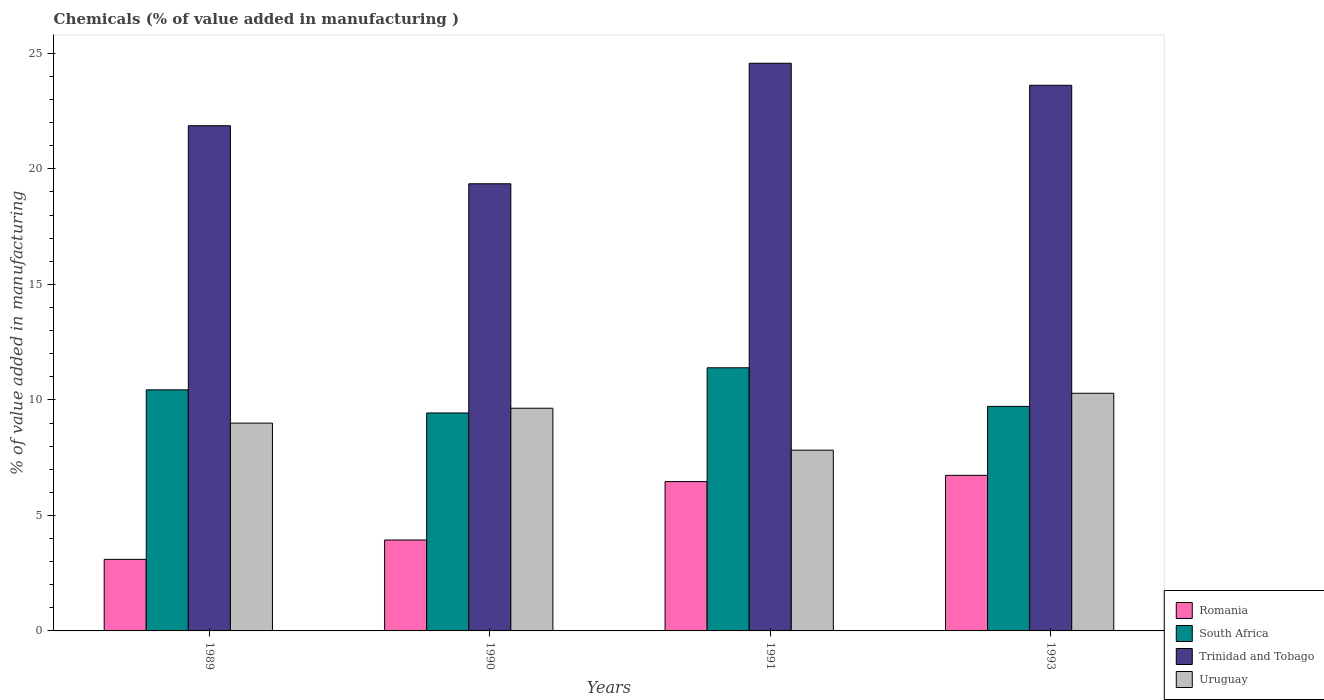How many groups of bars are there?
Your response must be concise. 4. Are the number of bars per tick equal to the number of legend labels?
Provide a short and direct response. Yes. Are the number of bars on each tick of the X-axis equal?
Your response must be concise. Yes. How many bars are there on the 3rd tick from the left?
Keep it short and to the point. 4. What is the label of the 4th group of bars from the left?
Your response must be concise. 1993. What is the value added in manufacturing chemicals in South Africa in 1990?
Your response must be concise. 9.44. Across all years, what is the maximum value added in manufacturing chemicals in South Africa?
Offer a very short reply. 11.39. Across all years, what is the minimum value added in manufacturing chemicals in Uruguay?
Your answer should be very brief. 7.82. In which year was the value added in manufacturing chemicals in Uruguay minimum?
Keep it short and to the point. 1991. What is the total value added in manufacturing chemicals in Trinidad and Tobago in the graph?
Give a very brief answer. 89.42. What is the difference between the value added in manufacturing chemicals in Romania in 1989 and that in 1990?
Your response must be concise. -0.84. What is the difference between the value added in manufacturing chemicals in Romania in 1991 and the value added in manufacturing chemicals in Uruguay in 1990?
Ensure brevity in your answer.  -3.18. What is the average value added in manufacturing chemicals in Uruguay per year?
Offer a terse response. 9.19. In the year 1993, what is the difference between the value added in manufacturing chemicals in Uruguay and value added in manufacturing chemicals in Trinidad and Tobago?
Provide a short and direct response. -13.33. In how many years, is the value added in manufacturing chemicals in South Africa greater than 18 %?
Keep it short and to the point. 0. What is the ratio of the value added in manufacturing chemicals in Uruguay in 1989 to that in 1990?
Make the answer very short. 0.93. What is the difference between the highest and the second highest value added in manufacturing chemicals in Trinidad and Tobago?
Your response must be concise. 0.95. What is the difference between the highest and the lowest value added in manufacturing chemicals in Romania?
Provide a succinct answer. 3.64. What does the 1st bar from the left in 1989 represents?
Make the answer very short. Romania. What does the 3rd bar from the right in 1990 represents?
Give a very brief answer. South Africa. Is it the case that in every year, the sum of the value added in manufacturing chemicals in Trinidad and Tobago and value added in manufacturing chemicals in South Africa is greater than the value added in manufacturing chemicals in Uruguay?
Keep it short and to the point. Yes. How many bars are there?
Keep it short and to the point. 16. Are all the bars in the graph horizontal?
Provide a short and direct response. No. Are the values on the major ticks of Y-axis written in scientific E-notation?
Offer a very short reply. No. Does the graph contain any zero values?
Make the answer very short. No. Where does the legend appear in the graph?
Make the answer very short. Bottom right. How are the legend labels stacked?
Make the answer very short. Vertical. What is the title of the graph?
Provide a succinct answer. Chemicals (% of value added in manufacturing ). What is the label or title of the X-axis?
Offer a terse response. Years. What is the label or title of the Y-axis?
Offer a terse response. % of value added in manufacturing. What is the % of value added in manufacturing of Romania in 1989?
Give a very brief answer. 3.1. What is the % of value added in manufacturing of South Africa in 1989?
Make the answer very short. 10.43. What is the % of value added in manufacturing in Trinidad and Tobago in 1989?
Offer a terse response. 21.87. What is the % of value added in manufacturing of Uruguay in 1989?
Your answer should be compact. 9. What is the % of value added in manufacturing of Romania in 1990?
Your answer should be compact. 3.94. What is the % of value added in manufacturing in South Africa in 1990?
Offer a terse response. 9.44. What is the % of value added in manufacturing in Trinidad and Tobago in 1990?
Offer a terse response. 19.36. What is the % of value added in manufacturing in Uruguay in 1990?
Ensure brevity in your answer.  9.64. What is the % of value added in manufacturing of Romania in 1991?
Your answer should be very brief. 6.46. What is the % of value added in manufacturing of South Africa in 1991?
Offer a terse response. 11.39. What is the % of value added in manufacturing of Trinidad and Tobago in 1991?
Your response must be concise. 24.57. What is the % of value added in manufacturing in Uruguay in 1991?
Offer a terse response. 7.82. What is the % of value added in manufacturing in Romania in 1993?
Your answer should be compact. 6.73. What is the % of value added in manufacturing in South Africa in 1993?
Your response must be concise. 9.72. What is the % of value added in manufacturing of Trinidad and Tobago in 1993?
Make the answer very short. 23.62. What is the % of value added in manufacturing of Uruguay in 1993?
Your answer should be compact. 10.29. Across all years, what is the maximum % of value added in manufacturing of Romania?
Offer a terse response. 6.73. Across all years, what is the maximum % of value added in manufacturing in South Africa?
Offer a terse response. 11.39. Across all years, what is the maximum % of value added in manufacturing of Trinidad and Tobago?
Give a very brief answer. 24.57. Across all years, what is the maximum % of value added in manufacturing of Uruguay?
Offer a very short reply. 10.29. Across all years, what is the minimum % of value added in manufacturing of Romania?
Keep it short and to the point. 3.1. Across all years, what is the minimum % of value added in manufacturing of South Africa?
Your answer should be very brief. 9.44. Across all years, what is the minimum % of value added in manufacturing in Trinidad and Tobago?
Provide a short and direct response. 19.36. Across all years, what is the minimum % of value added in manufacturing in Uruguay?
Your response must be concise. 7.82. What is the total % of value added in manufacturing in Romania in the graph?
Provide a short and direct response. 20.23. What is the total % of value added in manufacturing of South Africa in the graph?
Provide a succinct answer. 40.98. What is the total % of value added in manufacturing of Trinidad and Tobago in the graph?
Your answer should be compact. 89.42. What is the total % of value added in manufacturing in Uruguay in the graph?
Your response must be concise. 36.75. What is the difference between the % of value added in manufacturing in Romania in 1989 and that in 1990?
Make the answer very short. -0.84. What is the difference between the % of value added in manufacturing in South Africa in 1989 and that in 1990?
Give a very brief answer. 1. What is the difference between the % of value added in manufacturing of Trinidad and Tobago in 1989 and that in 1990?
Give a very brief answer. 2.51. What is the difference between the % of value added in manufacturing in Uruguay in 1989 and that in 1990?
Provide a succinct answer. -0.64. What is the difference between the % of value added in manufacturing in Romania in 1989 and that in 1991?
Keep it short and to the point. -3.37. What is the difference between the % of value added in manufacturing in South Africa in 1989 and that in 1991?
Give a very brief answer. -0.96. What is the difference between the % of value added in manufacturing in Trinidad and Tobago in 1989 and that in 1991?
Your answer should be compact. -2.7. What is the difference between the % of value added in manufacturing of Uruguay in 1989 and that in 1991?
Offer a terse response. 1.17. What is the difference between the % of value added in manufacturing of Romania in 1989 and that in 1993?
Ensure brevity in your answer.  -3.64. What is the difference between the % of value added in manufacturing of South Africa in 1989 and that in 1993?
Offer a very short reply. 0.72. What is the difference between the % of value added in manufacturing in Trinidad and Tobago in 1989 and that in 1993?
Provide a succinct answer. -1.75. What is the difference between the % of value added in manufacturing of Uruguay in 1989 and that in 1993?
Ensure brevity in your answer.  -1.29. What is the difference between the % of value added in manufacturing in Romania in 1990 and that in 1991?
Ensure brevity in your answer.  -2.53. What is the difference between the % of value added in manufacturing of South Africa in 1990 and that in 1991?
Offer a terse response. -1.96. What is the difference between the % of value added in manufacturing of Trinidad and Tobago in 1990 and that in 1991?
Make the answer very short. -5.22. What is the difference between the % of value added in manufacturing in Uruguay in 1990 and that in 1991?
Give a very brief answer. 1.82. What is the difference between the % of value added in manufacturing of Romania in 1990 and that in 1993?
Your answer should be compact. -2.8. What is the difference between the % of value added in manufacturing of South Africa in 1990 and that in 1993?
Give a very brief answer. -0.28. What is the difference between the % of value added in manufacturing in Trinidad and Tobago in 1990 and that in 1993?
Provide a succinct answer. -4.26. What is the difference between the % of value added in manufacturing of Uruguay in 1990 and that in 1993?
Your answer should be compact. -0.65. What is the difference between the % of value added in manufacturing in Romania in 1991 and that in 1993?
Give a very brief answer. -0.27. What is the difference between the % of value added in manufacturing of South Africa in 1991 and that in 1993?
Make the answer very short. 1.67. What is the difference between the % of value added in manufacturing in Trinidad and Tobago in 1991 and that in 1993?
Ensure brevity in your answer.  0.95. What is the difference between the % of value added in manufacturing in Uruguay in 1991 and that in 1993?
Make the answer very short. -2.46. What is the difference between the % of value added in manufacturing of Romania in 1989 and the % of value added in manufacturing of South Africa in 1990?
Keep it short and to the point. -6.34. What is the difference between the % of value added in manufacturing of Romania in 1989 and the % of value added in manufacturing of Trinidad and Tobago in 1990?
Your answer should be very brief. -16.26. What is the difference between the % of value added in manufacturing of Romania in 1989 and the % of value added in manufacturing of Uruguay in 1990?
Your answer should be compact. -6.54. What is the difference between the % of value added in manufacturing of South Africa in 1989 and the % of value added in manufacturing of Trinidad and Tobago in 1990?
Keep it short and to the point. -8.92. What is the difference between the % of value added in manufacturing in South Africa in 1989 and the % of value added in manufacturing in Uruguay in 1990?
Make the answer very short. 0.79. What is the difference between the % of value added in manufacturing of Trinidad and Tobago in 1989 and the % of value added in manufacturing of Uruguay in 1990?
Give a very brief answer. 12.23. What is the difference between the % of value added in manufacturing of Romania in 1989 and the % of value added in manufacturing of South Africa in 1991?
Provide a short and direct response. -8.29. What is the difference between the % of value added in manufacturing in Romania in 1989 and the % of value added in manufacturing in Trinidad and Tobago in 1991?
Offer a very short reply. -21.47. What is the difference between the % of value added in manufacturing of Romania in 1989 and the % of value added in manufacturing of Uruguay in 1991?
Your answer should be very brief. -4.73. What is the difference between the % of value added in manufacturing in South Africa in 1989 and the % of value added in manufacturing in Trinidad and Tobago in 1991?
Ensure brevity in your answer.  -14.14. What is the difference between the % of value added in manufacturing in South Africa in 1989 and the % of value added in manufacturing in Uruguay in 1991?
Make the answer very short. 2.61. What is the difference between the % of value added in manufacturing of Trinidad and Tobago in 1989 and the % of value added in manufacturing of Uruguay in 1991?
Give a very brief answer. 14.04. What is the difference between the % of value added in manufacturing of Romania in 1989 and the % of value added in manufacturing of South Africa in 1993?
Provide a succinct answer. -6.62. What is the difference between the % of value added in manufacturing in Romania in 1989 and the % of value added in manufacturing in Trinidad and Tobago in 1993?
Offer a very short reply. -20.52. What is the difference between the % of value added in manufacturing in Romania in 1989 and the % of value added in manufacturing in Uruguay in 1993?
Offer a very short reply. -7.19. What is the difference between the % of value added in manufacturing in South Africa in 1989 and the % of value added in manufacturing in Trinidad and Tobago in 1993?
Give a very brief answer. -13.18. What is the difference between the % of value added in manufacturing in South Africa in 1989 and the % of value added in manufacturing in Uruguay in 1993?
Your answer should be compact. 0.15. What is the difference between the % of value added in manufacturing of Trinidad and Tobago in 1989 and the % of value added in manufacturing of Uruguay in 1993?
Provide a succinct answer. 11.58. What is the difference between the % of value added in manufacturing of Romania in 1990 and the % of value added in manufacturing of South Africa in 1991?
Provide a succinct answer. -7.46. What is the difference between the % of value added in manufacturing of Romania in 1990 and the % of value added in manufacturing of Trinidad and Tobago in 1991?
Ensure brevity in your answer.  -20.64. What is the difference between the % of value added in manufacturing of Romania in 1990 and the % of value added in manufacturing of Uruguay in 1991?
Give a very brief answer. -3.89. What is the difference between the % of value added in manufacturing in South Africa in 1990 and the % of value added in manufacturing in Trinidad and Tobago in 1991?
Give a very brief answer. -15.14. What is the difference between the % of value added in manufacturing of South Africa in 1990 and the % of value added in manufacturing of Uruguay in 1991?
Provide a short and direct response. 1.61. What is the difference between the % of value added in manufacturing of Trinidad and Tobago in 1990 and the % of value added in manufacturing of Uruguay in 1991?
Offer a very short reply. 11.53. What is the difference between the % of value added in manufacturing in Romania in 1990 and the % of value added in manufacturing in South Africa in 1993?
Give a very brief answer. -5.78. What is the difference between the % of value added in manufacturing of Romania in 1990 and the % of value added in manufacturing of Trinidad and Tobago in 1993?
Your answer should be compact. -19.68. What is the difference between the % of value added in manufacturing of Romania in 1990 and the % of value added in manufacturing of Uruguay in 1993?
Your answer should be very brief. -6.35. What is the difference between the % of value added in manufacturing of South Africa in 1990 and the % of value added in manufacturing of Trinidad and Tobago in 1993?
Your response must be concise. -14.18. What is the difference between the % of value added in manufacturing in South Africa in 1990 and the % of value added in manufacturing in Uruguay in 1993?
Give a very brief answer. -0.85. What is the difference between the % of value added in manufacturing of Trinidad and Tobago in 1990 and the % of value added in manufacturing of Uruguay in 1993?
Ensure brevity in your answer.  9.07. What is the difference between the % of value added in manufacturing in Romania in 1991 and the % of value added in manufacturing in South Africa in 1993?
Give a very brief answer. -3.25. What is the difference between the % of value added in manufacturing in Romania in 1991 and the % of value added in manufacturing in Trinidad and Tobago in 1993?
Provide a succinct answer. -17.15. What is the difference between the % of value added in manufacturing in Romania in 1991 and the % of value added in manufacturing in Uruguay in 1993?
Your answer should be very brief. -3.82. What is the difference between the % of value added in manufacturing in South Africa in 1991 and the % of value added in manufacturing in Trinidad and Tobago in 1993?
Offer a terse response. -12.23. What is the difference between the % of value added in manufacturing of South Africa in 1991 and the % of value added in manufacturing of Uruguay in 1993?
Give a very brief answer. 1.1. What is the difference between the % of value added in manufacturing of Trinidad and Tobago in 1991 and the % of value added in manufacturing of Uruguay in 1993?
Provide a short and direct response. 14.28. What is the average % of value added in manufacturing of Romania per year?
Your response must be concise. 5.06. What is the average % of value added in manufacturing of South Africa per year?
Your answer should be very brief. 10.24. What is the average % of value added in manufacturing of Trinidad and Tobago per year?
Offer a terse response. 22.35. What is the average % of value added in manufacturing of Uruguay per year?
Your answer should be very brief. 9.19. In the year 1989, what is the difference between the % of value added in manufacturing of Romania and % of value added in manufacturing of South Africa?
Make the answer very short. -7.34. In the year 1989, what is the difference between the % of value added in manufacturing in Romania and % of value added in manufacturing in Trinidad and Tobago?
Give a very brief answer. -18.77. In the year 1989, what is the difference between the % of value added in manufacturing in Romania and % of value added in manufacturing in Uruguay?
Offer a very short reply. -5.9. In the year 1989, what is the difference between the % of value added in manufacturing in South Africa and % of value added in manufacturing in Trinidad and Tobago?
Ensure brevity in your answer.  -11.43. In the year 1989, what is the difference between the % of value added in manufacturing in South Africa and % of value added in manufacturing in Uruguay?
Your answer should be very brief. 1.44. In the year 1989, what is the difference between the % of value added in manufacturing of Trinidad and Tobago and % of value added in manufacturing of Uruguay?
Ensure brevity in your answer.  12.87. In the year 1990, what is the difference between the % of value added in manufacturing of Romania and % of value added in manufacturing of South Africa?
Keep it short and to the point. -5.5. In the year 1990, what is the difference between the % of value added in manufacturing of Romania and % of value added in manufacturing of Trinidad and Tobago?
Provide a succinct answer. -15.42. In the year 1990, what is the difference between the % of value added in manufacturing in Romania and % of value added in manufacturing in Uruguay?
Keep it short and to the point. -5.7. In the year 1990, what is the difference between the % of value added in manufacturing of South Africa and % of value added in manufacturing of Trinidad and Tobago?
Provide a succinct answer. -9.92. In the year 1990, what is the difference between the % of value added in manufacturing in South Africa and % of value added in manufacturing in Uruguay?
Your response must be concise. -0.2. In the year 1990, what is the difference between the % of value added in manufacturing of Trinidad and Tobago and % of value added in manufacturing of Uruguay?
Provide a short and direct response. 9.72. In the year 1991, what is the difference between the % of value added in manufacturing of Romania and % of value added in manufacturing of South Africa?
Provide a succinct answer. -4.93. In the year 1991, what is the difference between the % of value added in manufacturing in Romania and % of value added in manufacturing in Trinidad and Tobago?
Your answer should be compact. -18.11. In the year 1991, what is the difference between the % of value added in manufacturing of Romania and % of value added in manufacturing of Uruguay?
Offer a very short reply. -1.36. In the year 1991, what is the difference between the % of value added in manufacturing of South Africa and % of value added in manufacturing of Trinidad and Tobago?
Give a very brief answer. -13.18. In the year 1991, what is the difference between the % of value added in manufacturing of South Africa and % of value added in manufacturing of Uruguay?
Offer a terse response. 3.57. In the year 1991, what is the difference between the % of value added in manufacturing in Trinidad and Tobago and % of value added in manufacturing in Uruguay?
Keep it short and to the point. 16.75. In the year 1993, what is the difference between the % of value added in manufacturing in Romania and % of value added in manufacturing in South Africa?
Offer a very short reply. -2.98. In the year 1993, what is the difference between the % of value added in manufacturing of Romania and % of value added in manufacturing of Trinidad and Tobago?
Offer a terse response. -16.88. In the year 1993, what is the difference between the % of value added in manufacturing of Romania and % of value added in manufacturing of Uruguay?
Your answer should be very brief. -3.55. In the year 1993, what is the difference between the % of value added in manufacturing of South Africa and % of value added in manufacturing of Trinidad and Tobago?
Make the answer very short. -13.9. In the year 1993, what is the difference between the % of value added in manufacturing in South Africa and % of value added in manufacturing in Uruguay?
Your answer should be very brief. -0.57. In the year 1993, what is the difference between the % of value added in manufacturing in Trinidad and Tobago and % of value added in manufacturing in Uruguay?
Offer a terse response. 13.33. What is the ratio of the % of value added in manufacturing in Romania in 1989 to that in 1990?
Offer a very short reply. 0.79. What is the ratio of the % of value added in manufacturing of South Africa in 1989 to that in 1990?
Your response must be concise. 1.11. What is the ratio of the % of value added in manufacturing in Trinidad and Tobago in 1989 to that in 1990?
Your answer should be compact. 1.13. What is the ratio of the % of value added in manufacturing of Uruguay in 1989 to that in 1990?
Your answer should be compact. 0.93. What is the ratio of the % of value added in manufacturing of Romania in 1989 to that in 1991?
Make the answer very short. 0.48. What is the ratio of the % of value added in manufacturing of South Africa in 1989 to that in 1991?
Provide a short and direct response. 0.92. What is the ratio of the % of value added in manufacturing in Trinidad and Tobago in 1989 to that in 1991?
Your answer should be compact. 0.89. What is the ratio of the % of value added in manufacturing in Uruguay in 1989 to that in 1991?
Provide a succinct answer. 1.15. What is the ratio of the % of value added in manufacturing in Romania in 1989 to that in 1993?
Offer a terse response. 0.46. What is the ratio of the % of value added in manufacturing in South Africa in 1989 to that in 1993?
Your answer should be very brief. 1.07. What is the ratio of the % of value added in manufacturing of Trinidad and Tobago in 1989 to that in 1993?
Provide a succinct answer. 0.93. What is the ratio of the % of value added in manufacturing in Uruguay in 1989 to that in 1993?
Provide a short and direct response. 0.87. What is the ratio of the % of value added in manufacturing in Romania in 1990 to that in 1991?
Your answer should be compact. 0.61. What is the ratio of the % of value added in manufacturing of South Africa in 1990 to that in 1991?
Offer a very short reply. 0.83. What is the ratio of the % of value added in manufacturing of Trinidad and Tobago in 1990 to that in 1991?
Ensure brevity in your answer.  0.79. What is the ratio of the % of value added in manufacturing of Uruguay in 1990 to that in 1991?
Ensure brevity in your answer.  1.23. What is the ratio of the % of value added in manufacturing in Romania in 1990 to that in 1993?
Keep it short and to the point. 0.58. What is the ratio of the % of value added in manufacturing in South Africa in 1990 to that in 1993?
Keep it short and to the point. 0.97. What is the ratio of the % of value added in manufacturing of Trinidad and Tobago in 1990 to that in 1993?
Offer a terse response. 0.82. What is the ratio of the % of value added in manufacturing in Uruguay in 1990 to that in 1993?
Keep it short and to the point. 0.94. What is the ratio of the % of value added in manufacturing of Romania in 1991 to that in 1993?
Provide a short and direct response. 0.96. What is the ratio of the % of value added in manufacturing of South Africa in 1991 to that in 1993?
Your answer should be compact. 1.17. What is the ratio of the % of value added in manufacturing in Trinidad and Tobago in 1991 to that in 1993?
Provide a short and direct response. 1.04. What is the ratio of the % of value added in manufacturing in Uruguay in 1991 to that in 1993?
Provide a short and direct response. 0.76. What is the difference between the highest and the second highest % of value added in manufacturing in Romania?
Your answer should be very brief. 0.27. What is the difference between the highest and the second highest % of value added in manufacturing of South Africa?
Your answer should be compact. 0.96. What is the difference between the highest and the second highest % of value added in manufacturing of Trinidad and Tobago?
Your response must be concise. 0.95. What is the difference between the highest and the second highest % of value added in manufacturing in Uruguay?
Keep it short and to the point. 0.65. What is the difference between the highest and the lowest % of value added in manufacturing in Romania?
Make the answer very short. 3.64. What is the difference between the highest and the lowest % of value added in manufacturing in South Africa?
Ensure brevity in your answer.  1.96. What is the difference between the highest and the lowest % of value added in manufacturing in Trinidad and Tobago?
Provide a short and direct response. 5.22. What is the difference between the highest and the lowest % of value added in manufacturing of Uruguay?
Give a very brief answer. 2.46. 